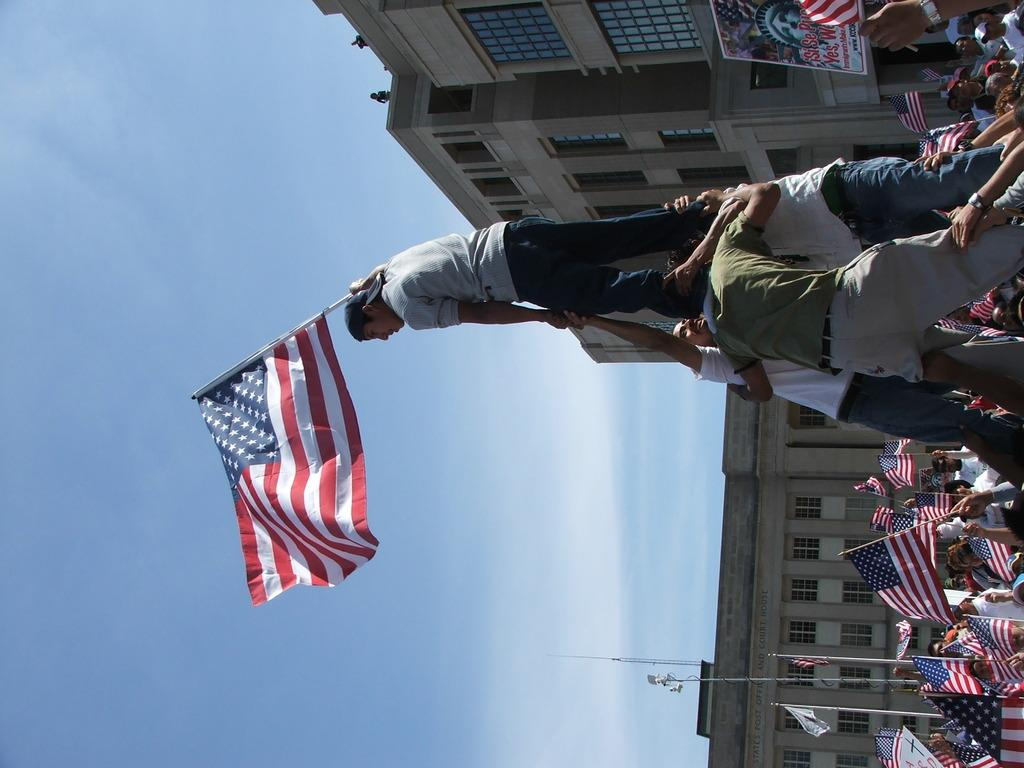What is happening in the center of the image? There is a person standing on a man in the center of the image. What is the person holding? The person is holding a flag. What can be seen in the background of the image? There are persons, flags, poles, a building, the sky, and clouds in the background of the image. Can you see the person's dad in the image? There is no mention of a dad or any family members in the image. Is the person crying in the image? There is no indication of the person's emotional state in the image. 